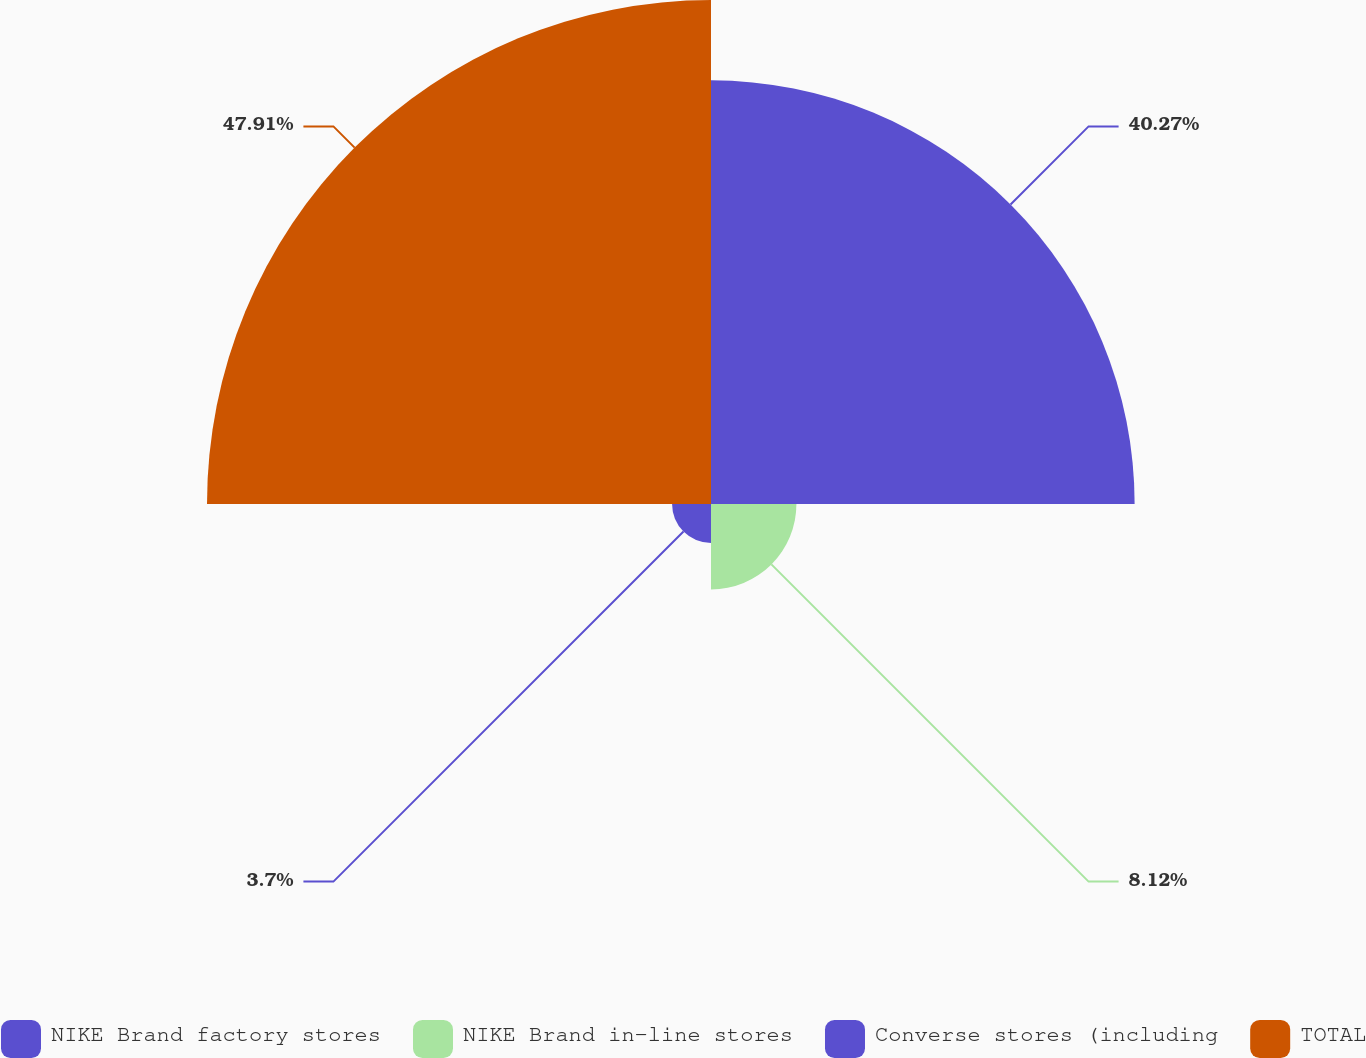Convert chart. <chart><loc_0><loc_0><loc_500><loc_500><pie_chart><fcel>NIKE Brand factory stores<fcel>NIKE Brand in-line stores<fcel>Converse stores (including<fcel>TOTAL<nl><fcel>40.27%<fcel>8.12%<fcel>3.7%<fcel>47.91%<nl></chart> 